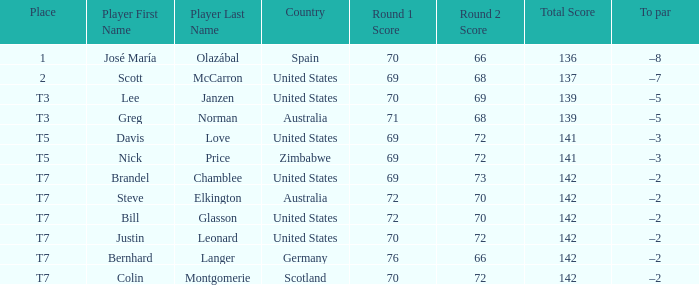Who is the Player with a Score of 70-72=142? Question 3 Justin Leonard, Colin Montgomerie. 